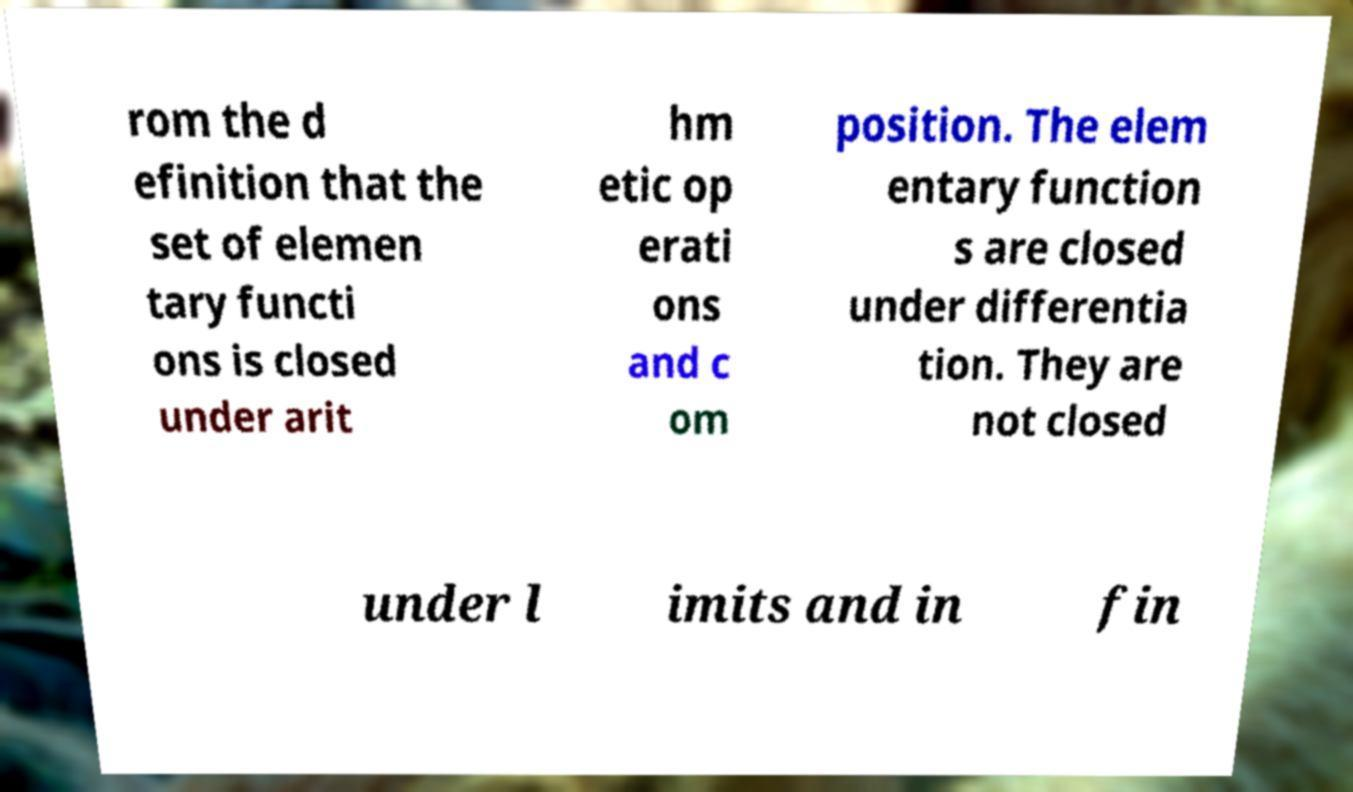What messages or text are displayed in this image? I need them in a readable, typed format. rom the d efinition that the set of elemen tary functi ons is closed under arit hm etic op erati ons and c om position. The elem entary function s are closed under differentia tion. They are not closed under l imits and in fin 